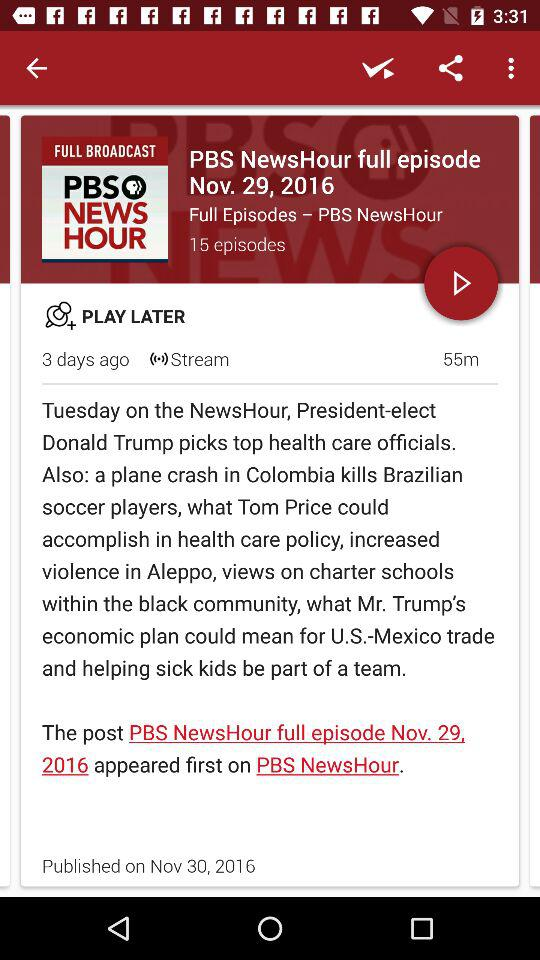What is the duration of the episode published on November 30, 2016? The duration of the episode is 55 minutes. 